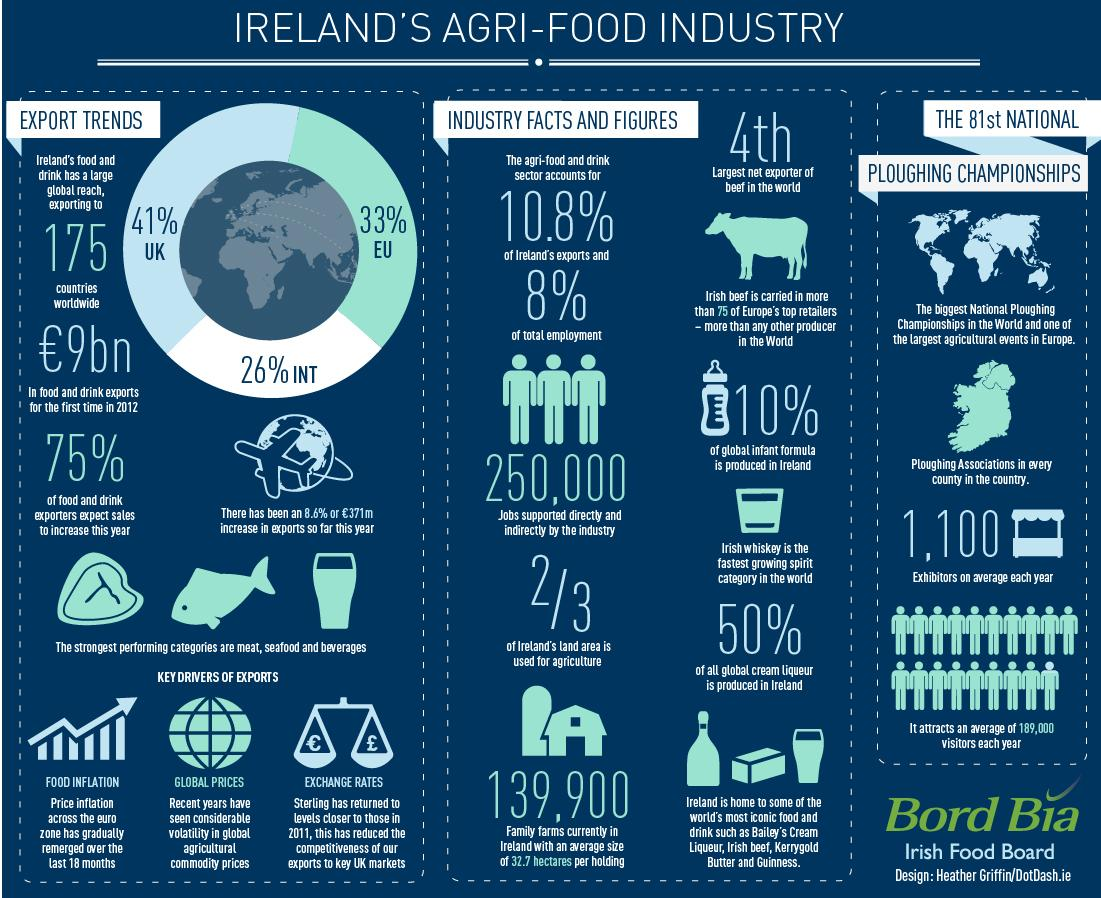Highlight a few significant elements in this photo. According to recent data, approximately 90% of the global infant formula is not produced in Ireland. A significant portion, approximately 41%, of Ireland's food and drink is exported to the United Kingdom. Approximately 50% of all global cream liqueur production is produced in Ireland. 